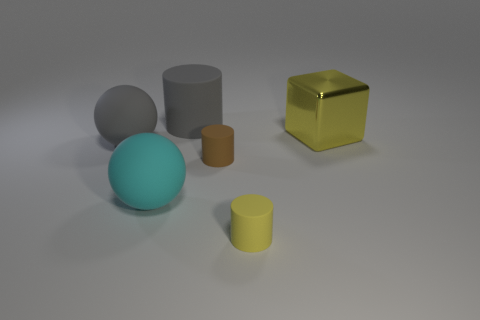Subtract all large rubber cylinders. How many cylinders are left? 2 Subtract all cyan spheres. How many spheres are left? 1 Subtract all spheres. How many objects are left? 4 Subtract all green things. Subtract all large yellow metallic blocks. How many objects are left? 5 Add 1 tiny matte cylinders. How many tiny matte cylinders are left? 3 Add 6 tiny yellow things. How many tiny yellow things exist? 7 Add 4 large yellow things. How many objects exist? 10 Subtract 0 gray cubes. How many objects are left? 6 Subtract 1 blocks. How many blocks are left? 0 Subtract all cyan cylinders. Subtract all red cubes. How many cylinders are left? 3 